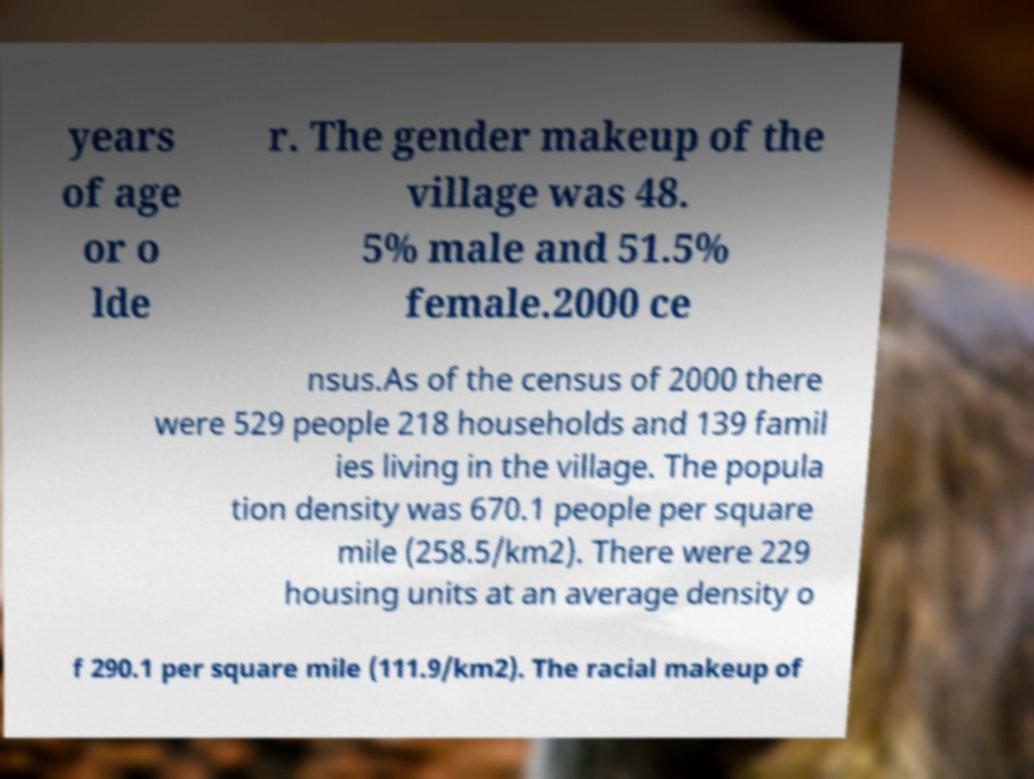For documentation purposes, I need the text within this image transcribed. Could you provide that? years of age or o lde r. The gender makeup of the village was 48. 5% male and 51.5% female.2000 ce nsus.As of the census of 2000 there were 529 people 218 households and 139 famil ies living in the village. The popula tion density was 670.1 people per square mile (258.5/km2). There were 229 housing units at an average density o f 290.1 per square mile (111.9/km2). The racial makeup of 